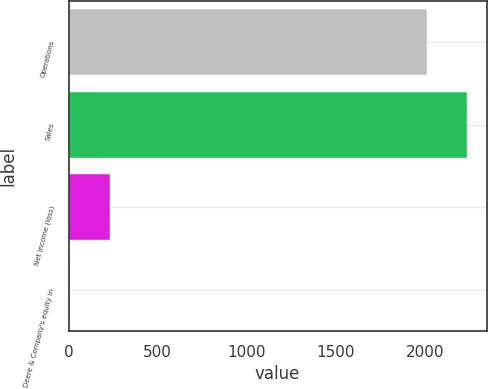Convert chart. <chart><loc_0><loc_0><loc_500><loc_500><bar_chart><fcel>Operations<fcel>Sales<fcel>Net income (loss)<fcel>Deere & Company's equity in<nl><fcel>2011<fcel>2233.4<fcel>231.4<fcel>9<nl></chart> 